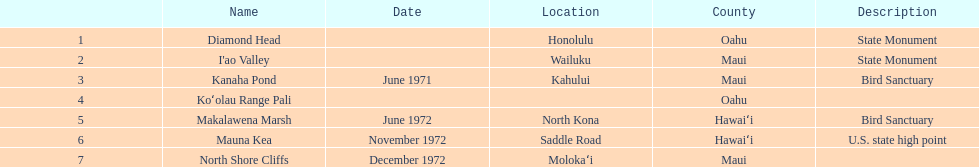What's the complete number of landmarks present in maui? 3. 